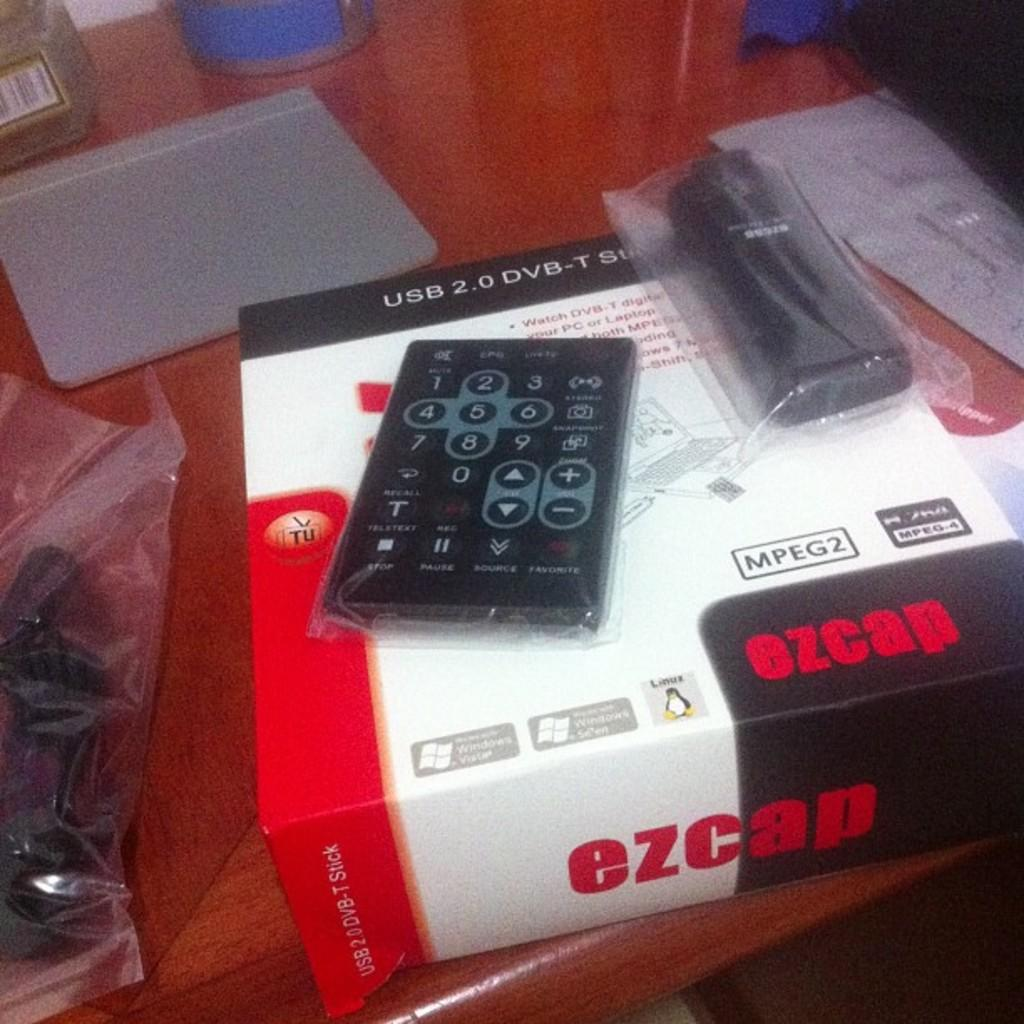<image>
Describe the image concisely. the word ezcap is on the side of the item 